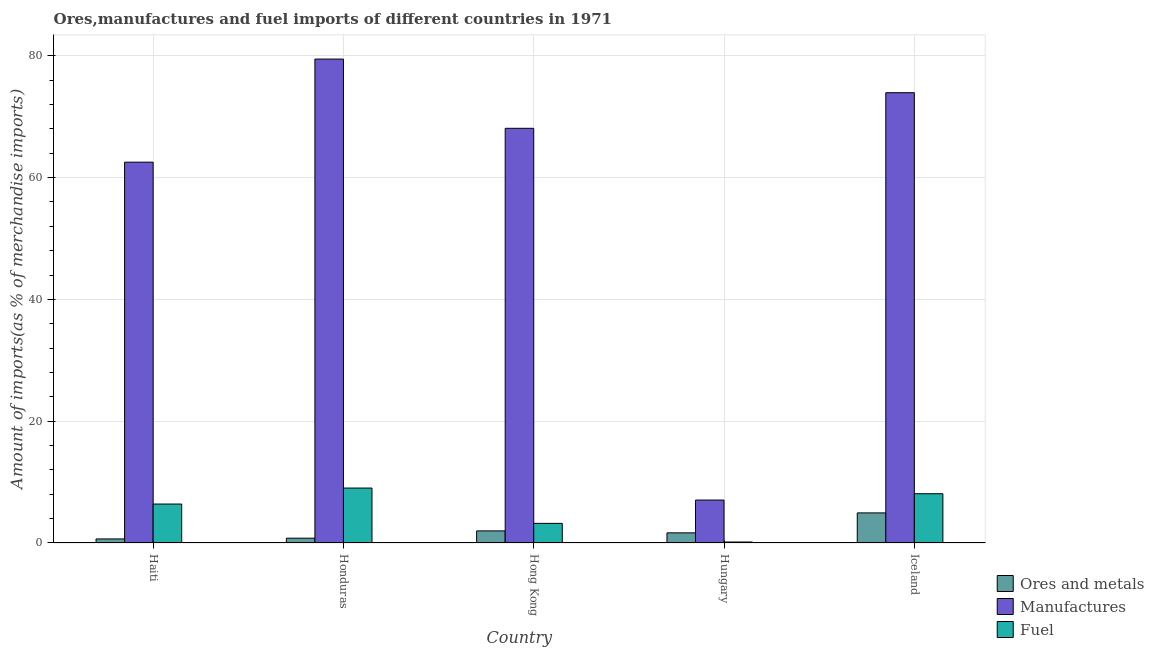How many groups of bars are there?
Your answer should be very brief. 5. Are the number of bars per tick equal to the number of legend labels?
Your answer should be compact. Yes. Are the number of bars on each tick of the X-axis equal?
Provide a succinct answer. Yes. What is the label of the 2nd group of bars from the left?
Provide a succinct answer. Honduras. In how many cases, is the number of bars for a given country not equal to the number of legend labels?
Offer a terse response. 0. What is the percentage of fuel imports in Haiti?
Offer a very short reply. 6.4. Across all countries, what is the maximum percentage of manufactures imports?
Keep it short and to the point. 79.47. Across all countries, what is the minimum percentage of manufactures imports?
Make the answer very short. 7.05. In which country was the percentage of ores and metals imports maximum?
Ensure brevity in your answer.  Iceland. In which country was the percentage of manufactures imports minimum?
Offer a very short reply. Hungary. What is the total percentage of manufactures imports in the graph?
Ensure brevity in your answer.  291.11. What is the difference between the percentage of ores and metals imports in Honduras and that in Hungary?
Offer a very short reply. -0.87. What is the difference between the percentage of ores and metals imports in Haiti and the percentage of fuel imports in Hong Kong?
Offer a terse response. -2.56. What is the average percentage of manufactures imports per country?
Your answer should be very brief. 58.22. What is the difference between the percentage of manufactures imports and percentage of ores and metals imports in Honduras?
Make the answer very short. 78.68. In how many countries, is the percentage of fuel imports greater than 20 %?
Your response must be concise. 0. What is the ratio of the percentage of manufactures imports in Honduras to that in Hong Kong?
Offer a terse response. 1.17. Is the difference between the percentage of manufactures imports in Honduras and Iceland greater than the difference between the percentage of ores and metals imports in Honduras and Iceland?
Your answer should be compact. Yes. What is the difference between the highest and the second highest percentage of fuel imports?
Your answer should be very brief. 0.93. What is the difference between the highest and the lowest percentage of ores and metals imports?
Make the answer very short. 4.27. In how many countries, is the percentage of fuel imports greater than the average percentage of fuel imports taken over all countries?
Make the answer very short. 3. What does the 3rd bar from the left in Hungary represents?
Provide a short and direct response. Fuel. What does the 3rd bar from the right in Iceland represents?
Your answer should be very brief. Ores and metals. Is it the case that in every country, the sum of the percentage of ores and metals imports and percentage of manufactures imports is greater than the percentage of fuel imports?
Keep it short and to the point. Yes. How many bars are there?
Make the answer very short. 15. Are all the bars in the graph horizontal?
Your response must be concise. No. How many countries are there in the graph?
Your answer should be compact. 5. Does the graph contain any zero values?
Provide a succinct answer. No. How many legend labels are there?
Keep it short and to the point. 3. How are the legend labels stacked?
Your answer should be very brief. Vertical. What is the title of the graph?
Provide a short and direct response. Ores,manufactures and fuel imports of different countries in 1971. What is the label or title of the Y-axis?
Your response must be concise. Amount of imports(as % of merchandise imports). What is the Amount of imports(as % of merchandise imports) of Ores and metals in Haiti?
Provide a succinct answer. 0.67. What is the Amount of imports(as % of merchandise imports) in Manufactures in Haiti?
Keep it short and to the point. 62.54. What is the Amount of imports(as % of merchandise imports) in Fuel in Haiti?
Ensure brevity in your answer.  6.4. What is the Amount of imports(as % of merchandise imports) in Ores and metals in Honduras?
Offer a very short reply. 0.79. What is the Amount of imports(as % of merchandise imports) of Manufactures in Honduras?
Your response must be concise. 79.47. What is the Amount of imports(as % of merchandise imports) of Fuel in Honduras?
Provide a succinct answer. 9.02. What is the Amount of imports(as % of merchandise imports) in Ores and metals in Hong Kong?
Offer a very short reply. 1.99. What is the Amount of imports(as % of merchandise imports) in Manufactures in Hong Kong?
Your response must be concise. 68.1. What is the Amount of imports(as % of merchandise imports) of Fuel in Hong Kong?
Your answer should be compact. 3.22. What is the Amount of imports(as % of merchandise imports) of Ores and metals in Hungary?
Keep it short and to the point. 1.66. What is the Amount of imports(as % of merchandise imports) of Manufactures in Hungary?
Your response must be concise. 7.05. What is the Amount of imports(as % of merchandise imports) of Fuel in Hungary?
Give a very brief answer. 0.16. What is the Amount of imports(as % of merchandise imports) of Ores and metals in Iceland?
Your answer should be very brief. 4.94. What is the Amount of imports(as % of merchandise imports) in Manufactures in Iceland?
Your answer should be compact. 73.95. What is the Amount of imports(as % of merchandise imports) in Fuel in Iceland?
Your answer should be very brief. 8.09. Across all countries, what is the maximum Amount of imports(as % of merchandise imports) in Ores and metals?
Offer a terse response. 4.94. Across all countries, what is the maximum Amount of imports(as % of merchandise imports) of Manufactures?
Give a very brief answer. 79.47. Across all countries, what is the maximum Amount of imports(as % of merchandise imports) of Fuel?
Provide a short and direct response. 9.02. Across all countries, what is the minimum Amount of imports(as % of merchandise imports) of Ores and metals?
Your response must be concise. 0.67. Across all countries, what is the minimum Amount of imports(as % of merchandise imports) in Manufactures?
Your answer should be very brief. 7.05. Across all countries, what is the minimum Amount of imports(as % of merchandise imports) in Fuel?
Give a very brief answer. 0.16. What is the total Amount of imports(as % of merchandise imports) in Ores and metals in the graph?
Provide a short and direct response. 10.05. What is the total Amount of imports(as % of merchandise imports) of Manufactures in the graph?
Ensure brevity in your answer.  291.11. What is the total Amount of imports(as % of merchandise imports) of Fuel in the graph?
Keep it short and to the point. 26.89. What is the difference between the Amount of imports(as % of merchandise imports) of Ores and metals in Haiti and that in Honduras?
Keep it short and to the point. -0.12. What is the difference between the Amount of imports(as % of merchandise imports) of Manufactures in Haiti and that in Honduras?
Offer a terse response. -16.93. What is the difference between the Amount of imports(as % of merchandise imports) of Fuel in Haiti and that in Honduras?
Your answer should be very brief. -2.62. What is the difference between the Amount of imports(as % of merchandise imports) in Ores and metals in Haiti and that in Hong Kong?
Make the answer very short. -1.32. What is the difference between the Amount of imports(as % of merchandise imports) in Manufactures in Haiti and that in Hong Kong?
Your response must be concise. -5.56. What is the difference between the Amount of imports(as % of merchandise imports) of Fuel in Haiti and that in Hong Kong?
Ensure brevity in your answer.  3.17. What is the difference between the Amount of imports(as % of merchandise imports) in Ores and metals in Haiti and that in Hungary?
Make the answer very short. -1. What is the difference between the Amount of imports(as % of merchandise imports) of Manufactures in Haiti and that in Hungary?
Give a very brief answer. 55.49. What is the difference between the Amount of imports(as % of merchandise imports) of Fuel in Haiti and that in Hungary?
Offer a very short reply. 6.24. What is the difference between the Amount of imports(as % of merchandise imports) of Ores and metals in Haiti and that in Iceland?
Your answer should be compact. -4.27. What is the difference between the Amount of imports(as % of merchandise imports) in Manufactures in Haiti and that in Iceland?
Keep it short and to the point. -11.41. What is the difference between the Amount of imports(as % of merchandise imports) in Fuel in Haiti and that in Iceland?
Offer a terse response. -1.69. What is the difference between the Amount of imports(as % of merchandise imports) of Ores and metals in Honduras and that in Hong Kong?
Provide a succinct answer. -1.2. What is the difference between the Amount of imports(as % of merchandise imports) of Manufactures in Honduras and that in Hong Kong?
Your answer should be very brief. 11.37. What is the difference between the Amount of imports(as % of merchandise imports) of Fuel in Honduras and that in Hong Kong?
Give a very brief answer. 5.8. What is the difference between the Amount of imports(as % of merchandise imports) in Ores and metals in Honduras and that in Hungary?
Provide a succinct answer. -0.88. What is the difference between the Amount of imports(as % of merchandise imports) in Manufactures in Honduras and that in Hungary?
Your response must be concise. 72.42. What is the difference between the Amount of imports(as % of merchandise imports) of Fuel in Honduras and that in Hungary?
Provide a succinct answer. 8.86. What is the difference between the Amount of imports(as % of merchandise imports) in Ores and metals in Honduras and that in Iceland?
Give a very brief answer. -4.15. What is the difference between the Amount of imports(as % of merchandise imports) in Manufactures in Honduras and that in Iceland?
Provide a succinct answer. 5.52. What is the difference between the Amount of imports(as % of merchandise imports) in Fuel in Honduras and that in Iceland?
Offer a terse response. 0.93. What is the difference between the Amount of imports(as % of merchandise imports) in Ores and metals in Hong Kong and that in Hungary?
Your answer should be very brief. 0.32. What is the difference between the Amount of imports(as % of merchandise imports) of Manufactures in Hong Kong and that in Hungary?
Offer a terse response. 61.05. What is the difference between the Amount of imports(as % of merchandise imports) in Fuel in Hong Kong and that in Hungary?
Your response must be concise. 3.06. What is the difference between the Amount of imports(as % of merchandise imports) in Ores and metals in Hong Kong and that in Iceland?
Offer a terse response. -2.95. What is the difference between the Amount of imports(as % of merchandise imports) in Manufactures in Hong Kong and that in Iceland?
Your answer should be very brief. -5.85. What is the difference between the Amount of imports(as % of merchandise imports) in Fuel in Hong Kong and that in Iceland?
Offer a terse response. -4.87. What is the difference between the Amount of imports(as % of merchandise imports) of Ores and metals in Hungary and that in Iceland?
Your response must be concise. -3.28. What is the difference between the Amount of imports(as % of merchandise imports) in Manufactures in Hungary and that in Iceland?
Your response must be concise. -66.9. What is the difference between the Amount of imports(as % of merchandise imports) of Fuel in Hungary and that in Iceland?
Provide a short and direct response. -7.93. What is the difference between the Amount of imports(as % of merchandise imports) in Ores and metals in Haiti and the Amount of imports(as % of merchandise imports) in Manufactures in Honduras?
Offer a terse response. -78.8. What is the difference between the Amount of imports(as % of merchandise imports) in Ores and metals in Haiti and the Amount of imports(as % of merchandise imports) in Fuel in Honduras?
Provide a short and direct response. -8.35. What is the difference between the Amount of imports(as % of merchandise imports) of Manufactures in Haiti and the Amount of imports(as % of merchandise imports) of Fuel in Honduras?
Ensure brevity in your answer.  53.52. What is the difference between the Amount of imports(as % of merchandise imports) in Ores and metals in Haiti and the Amount of imports(as % of merchandise imports) in Manufactures in Hong Kong?
Provide a succinct answer. -67.43. What is the difference between the Amount of imports(as % of merchandise imports) of Ores and metals in Haiti and the Amount of imports(as % of merchandise imports) of Fuel in Hong Kong?
Provide a short and direct response. -2.56. What is the difference between the Amount of imports(as % of merchandise imports) in Manufactures in Haiti and the Amount of imports(as % of merchandise imports) in Fuel in Hong Kong?
Provide a short and direct response. 59.32. What is the difference between the Amount of imports(as % of merchandise imports) in Ores and metals in Haiti and the Amount of imports(as % of merchandise imports) in Manufactures in Hungary?
Give a very brief answer. -6.38. What is the difference between the Amount of imports(as % of merchandise imports) in Ores and metals in Haiti and the Amount of imports(as % of merchandise imports) in Fuel in Hungary?
Your answer should be very brief. 0.51. What is the difference between the Amount of imports(as % of merchandise imports) of Manufactures in Haiti and the Amount of imports(as % of merchandise imports) of Fuel in Hungary?
Provide a succinct answer. 62.38. What is the difference between the Amount of imports(as % of merchandise imports) of Ores and metals in Haiti and the Amount of imports(as % of merchandise imports) of Manufactures in Iceland?
Keep it short and to the point. -73.28. What is the difference between the Amount of imports(as % of merchandise imports) in Ores and metals in Haiti and the Amount of imports(as % of merchandise imports) in Fuel in Iceland?
Your answer should be very brief. -7.42. What is the difference between the Amount of imports(as % of merchandise imports) of Manufactures in Haiti and the Amount of imports(as % of merchandise imports) of Fuel in Iceland?
Ensure brevity in your answer.  54.45. What is the difference between the Amount of imports(as % of merchandise imports) of Ores and metals in Honduras and the Amount of imports(as % of merchandise imports) of Manufactures in Hong Kong?
Make the answer very short. -67.31. What is the difference between the Amount of imports(as % of merchandise imports) in Ores and metals in Honduras and the Amount of imports(as % of merchandise imports) in Fuel in Hong Kong?
Give a very brief answer. -2.43. What is the difference between the Amount of imports(as % of merchandise imports) of Manufactures in Honduras and the Amount of imports(as % of merchandise imports) of Fuel in Hong Kong?
Offer a terse response. 76.25. What is the difference between the Amount of imports(as % of merchandise imports) of Ores and metals in Honduras and the Amount of imports(as % of merchandise imports) of Manufactures in Hungary?
Provide a short and direct response. -6.26. What is the difference between the Amount of imports(as % of merchandise imports) of Ores and metals in Honduras and the Amount of imports(as % of merchandise imports) of Fuel in Hungary?
Offer a very short reply. 0.63. What is the difference between the Amount of imports(as % of merchandise imports) of Manufactures in Honduras and the Amount of imports(as % of merchandise imports) of Fuel in Hungary?
Your response must be concise. 79.31. What is the difference between the Amount of imports(as % of merchandise imports) in Ores and metals in Honduras and the Amount of imports(as % of merchandise imports) in Manufactures in Iceland?
Offer a very short reply. -73.16. What is the difference between the Amount of imports(as % of merchandise imports) of Ores and metals in Honduras and the Amount of imports(as % of merchandise imports) of Fuel in Iceland?
Ensure brevity in your answer.  -7.3. What is the difference between the Amount of imports(as % of merchandise imports) of Manufactures in Honduras and the Amount of imports(as % of merchandise imports) of Fuel in Iceland?
Ensure brevity in your answer.  71.38. What is the difference between the Amount of imports(as % of merchandise imports) of Ores and metals in Hong Kong and the Amount of imports(as % of merchandise imports) of Manufactures in Hungary?
Provide a succinct answer. -5.06. What is the difference between the Amount of imports(as % of merchandise imports) of Ores and metals in Hong Kong and the Amount of imports(as % of merchandise imports) of Fuel in Hungary?
Your answer should be compact. 1.83. What is the difference between the Amount of imports(as % of merchandise imports) in Manufactures in Hong Kong and the Amount of imports(as % of merchandise imports) in Fuel in Hungary?
Your response must be concise. 67.94. What is the difference between the Amount of imports(as % of merchandise imports) of Ores and metals in Hong Kong and the Amount of imports(as % of merchandise imports) of Manufactures in Iceland?
Offer a very short reply. -71.96. What is the difference between the Amount of imports(as % of merchandise imports) of Ores and metals in Hong Kong and the Amount of imports(as % of merchandise imports) of Fuel in Iceland?
Your answer should be compact. -6.1. What is the difference between the Amount of imports(as % of merchandise imports) of Manufactures in Hong Kong and the Amount of imports(as % of merchandise imports) of Fuel in Iceland?
Give a very brief answer. 60.01. What is the difference between the Amount of imports(as % of merchandise imports) of Ores and metals in Hungary and the Amount of imports(as % of merchandise imports) of Manufactures in Iceland?
Provide a succinct answer. -72.28. What is the difference between the Amount of imports(as % of merchandise imports) of Ores and metals in Hungary and the Amount of imports(as % of merchandise imports) of Fuel in Iceland?
Make the answer very short. -6.43. What is the difference between the Amount of imports(as % of merchandise imports) in Manufactures in Hungary and the Amount of imports(as % of merchandise imports) in Fuel in Iceland?
Make the answer very short. -1.04. What is the average Amount of imports(as % of merchandise imports) of Ores and metals per country?
Offer a very short reply. 2.01. What is the average Amount of imports(as % of merchandise imports) in Manufactures per country?
Your answer should be very brief. 58.22. What is the average Amount of imports(as % of merchandise imports) of Fuel per country?
Offer a very short reply. 5.38. What is the difference between the Amount of imports(as % of merchandise imports) in Ores and metals and Amount of imports(as % of merchandise imports) in Manufactures in Haiti?
Your answer should be compact. -61.87. What is the difference between the Amount of imports(as % of merchandise imports) of Ores and metals and Amount of imports(as % of merchandise imports) of Fuel in Haiti?
Your response must be concise. -5.73. What is the difference between the Amount of imports(as % of merchandise imports) of Manufactures and Amount of imports(as % of merchandise imports) of Fuel in Haiti?
Your response must be concise. 56.14. What is the difference between the Amount of imports(as % of merchandise imports) in Ores and metals and Amount of imports(as % of merchandise imports) in Manufactures in Honduras?
Keep it short and to the point. -78.68. What is the difference between the Amount of imports(as % of merchandise imports) in Ores and metals and Amount of imports(as % of merchandise imports) in Fuel in Honduras?
Provide a succinct answer. -8.23. What is the difference between the Amount of imports(as % of merchandise imports) of Manufactures and Amount of imports(as % of merchandise imports) of Fuel in Honduras?
Ensure brevity in your answer.  70.45. What is the difference between the Amount of imports(as % of merchandise imports) of Ores and metals and Amount of imports(as % of merchandise imports) of Manufactures in Hong Kong?
Give a very brief answer. -66.11. What is the difference between the Amount of imports(as % of merchandise imports) of Ores and metals and Amount of imports(as % of merchandise imports) of Fuel in Hong Kong?
Make the answer very short. -1.23. What is the difference between the Amount of imports(as % of merchandise imports) in Manufactures and Amount of imports(as % of merchandise imports) in Fuel in Hong Kong?
Keep it short and to the point. 64.88. What is the difference between the Amount of imports(as % of merchandise imports) in Ores and metals and Amount of imports(as % of merchandise imports) in Manufactures in Hungary?
Your response must be concise. -5.39. What is the difference between the Amount of imports(as % of merchandise imports) in Ores and metals and Amount of imports(as % of merchandise imports) in Fuel in Hungary?
Your answer should be compact. 1.5. What is the difference between the Amount of imports(as % of merchandise imports) in Manufactures and Amount of imports(as % of merchandise imports) in Fuel in Hungary?
Make the answer very short. 6.89. What is the difference between the Amount of imports(as % of merchandise imports) in Ores and metals and Amount of imports(as % of merchandise imports) in Manufactures in Iceland?
Provide a succinct answer. -69.01. What is the difference between the Amount of imports(as % of merchandise imports) in Ores and metals and Amount of imports(as % of merchandise imports) in Fuel in Iceland?
Your answer should be very brief. -3.15. What is the difference between the Amount of imports(as % of merchandise imports) in Manufactures and Amount of imports(as % of merchandise imports) in Fuel in Iceland?
Make the answer very short. 65.86. What is the ratio of the Amount of imports(as % of merchandise imports) of Ores and metals in Haiti to that in Honduras?
Provide a short and direct response. 0.85. What is the ratio of the Amount of imports(as % of merchandise imports) of Manufactures in Haiti to that in Honduras?
Provide a succinct answer. 0.79. What is the ratio of the Amount of imports(as % of merchandise imports) in Fuel in Haiti to that in Honduras?
Provide a succinct answer. 0.71. What is the ratio of the Amount of imports(as % of merchandise imports) of Ores and metals in Haiti to that in Hong Kong?
Ensure brevity in your answer.  0.34. What is the ratio of the Amount of imports(as % of merchandise imports) of Manufactures in Haiti to that in Hong Kong?
Offer a terse response. 0.92. What is the ratio of the Amount of imports(as % of merchandise imports) of Fuel in Haiti to that in Hong Kong?
Offer a terse response. 1.99. What is the ratio of the Amount of imports(as % of merchandise imports) in Ores and metals in Haiti to that in Hungary?
Make the answer very short. 0.4. What is the ratio of the Amount of imports(as % of merchandise imports) in Manufactures in Haiti to that in Hungary?
Provide a short and direct response. 8.87. What is the ratio of the Amount of imports(as % of merchandise imports) of Fuel in Haiti to that in Hungary?
Provide a short and direct response. 39.65. What is the ratio of the Amount of imports(as % of merchandise imports) in Ores and metals in Haiti to that in Iceland?
Ensure brevity in your answer.  0.14. What is the ratio of the Amount of imports(as % of merchandise imports) in Manufactures in Haiti to that in Iceland?
Provide a short and direct response. 0.85. What is the ratio of the Amount of imports(as % of merchandise imports) of Fuel in Haiti to that in Iceland?
Your answer should be compact. 0.79. What is the ratio of the Amount of imports(as % of merchandise imports) in Ores and metals in Honduras to that in Hong Kong?
Offer a terse response. 0.4. What is the ratio of the Amount of imports(as % of merchandise imports) of Manufactures in Honduras to that in Hong Kong?
Provide a short and direct response. 1.17. What is the ratio of the Amount of imports(as % of merchandise imports) in Fuel in Honduras to that in Hong Kong?
Keep it short and to the point. 2.8. What is the ratio of the Amount of imports(as % of merchandise imports) in Ores and metals in Honduras to that in Hungary?
Your answer should be very brief. 0.47. What is the ratio of the Amount of imports(as % of merchandise imports) in Manufactures in Honduras to that in Hungary?
Provide a succinct answer. 11.27. What is the ratio of the Amount of imports(as % of merchandise imports) of Fuel in Honduras to that in Hungary?
Give a very brief answer. 55.92. What is the ratio of the Amount of imports(as % of merchandise imports) in Ores and metals in Honduras to that in Iceland?
Make the answer very short. 0.16. What is the ratio of the Amount of imports(as % of merchandise imports) of Manufactures in Honduras to that in Iceland?
Your answer should be compact. 1.07. What is the ratio of the Amount of imports(as % of merchandise imports) of Fuel in Honduras to that in Iceland?
Ensure brevity in your answer.  1.12. What is the ratio of the Amount of imports(as % of merchandise imports) in Ores and metals in Hong Kong to that in Hungary?
Provide a succinct answer. 1.2. What is the ratio of the Amount of imports(as % of merchandise imports) in Manufactures in Hong Kong to that in Hungary?
Keep it short and to the point. 9.66. What is the ratio of the Amount of imports(as % of merchandise imports) of Fuel in Hong Kong to that in Hungary?
Give a very brief answer. 19.97. What is the ratio of the Amount of imports(as % of merchandise imports) of Ores and metals in Hong Kong to that in Iceland?
Provide a succinct answer. 0.4. What is the ratio of the Amount of imports(as % of merchandise imports) in Manufactures in Hong Kong to that in Iceland?
Give a very brief answer. 0.92. What is the ratio of the Amount of imports(as % of merchandise imports) in Fuel in Hong Kong to that in Iceland?
Your answer should be very brief. 0.4. What is the ratio of the Amount of imports(as % of merchandise imports) of Ores and metals in Hungary to that in Iceland?
Your answer should be very brief. 0.34. What is the ratio of the Amount of imports(as % of merchandise imports) in Manufactures in Hungary to that in Iceland?
Make the answer very short. 0.1. What is the ratio of the Amount of imports(as % of merchandise imports) in Fuel in Hungary to that in Iceland?
Provide a short and direct response. 0.02. What is the difference between the highest and the second highest Amount of imports(as % of merchandise imports) of Ores and metals?
Your answer should be very brief. 2.95. What is the difference between the highest and the second highest Amount of imports(as % of merchandise imports) in Manufactures?
Provide a short and direct response. 5.52. What is the difference between the highest and the second highest Amount of imports(as % of merchandise imports) in Fuel?
Ensure brevity in your answer.  0.93. What is the difference between the highest and the lowest Amount of imports(as % of merchandise imports) of Ores and metals?
Your answer should be very brief. 4.27. What is the difference between the highest and the lowest Amount of imports(as % of merchandise imports) in Manufactures?
Make the answer very short. 72.42. What is the difference between the highest and the lowest Amount of imports(as % of merchandise imports) of Fuel?
Offer a very short reply. 8.86. 